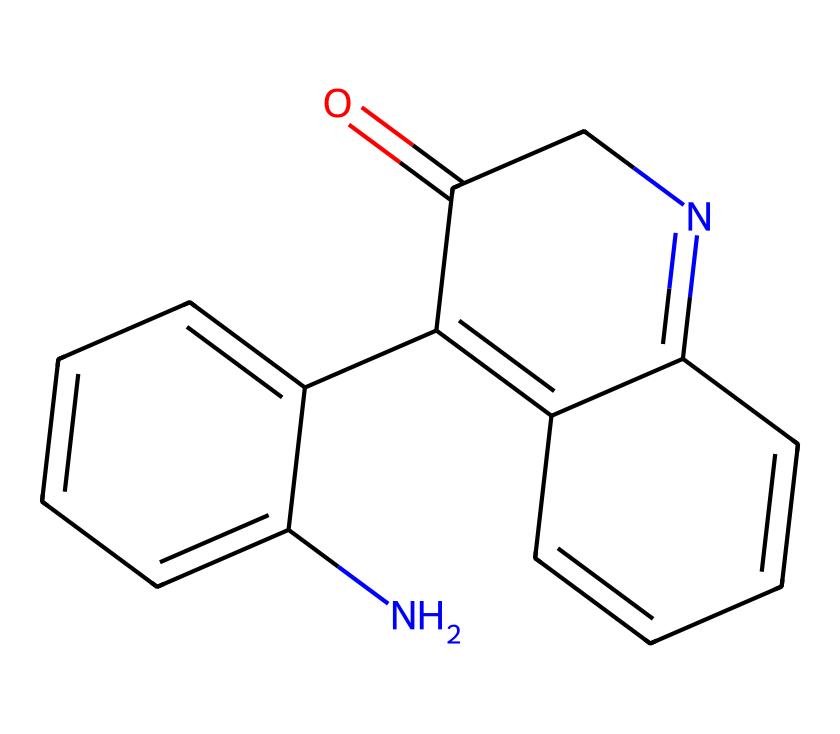What is the molecular formula of the chemical represented? By analyzing the SMILES representation, we deduce that the elemental composition is derived from counting the atoms of each element present; there are 14 carbon (C), 10 hydrogen (H), 2 nitrogen (N), and 1 oxygen (O).
Answer: C14H10N2O How many rings are present in the structure? The structure depicts a fused bicyclic system, indicating there are two distinct rings within the chemical structure as inferred from the numerical identifiers in the SMILES string.
Answer: 2 What types of chemical bonds are present? The presence of multiple double bonds can be inferred from the "=" symbol in the SMILES notation; in total, there are several carbon-carbon and carbon-nitrogen double bonds, indicating unsaturation.
Answer: double bonds What functional group can be identified in this structure? The representation shows a carbonyl group (C=O) due to the presence of oxygen attached to carbon with a double bond. This is critical in identifying the functional properties of the compound.
Answer: carbonyl group What is the primary type of compound this structure represents? The presence of multiple aromatic rings, nitrogen atoms, and specific functional groups indicates this molecule is likely a type of alkaloid, which is commonly found in natural dyes used for colorants.
Answer: alkaloid How many nitrogen atoms are present in the molecule? By reviewing the SMILES notation, it's observed that two nitrogen atoms are explicitly indicated, counted directly from the letter "N" within the structure.
Answer: 2 